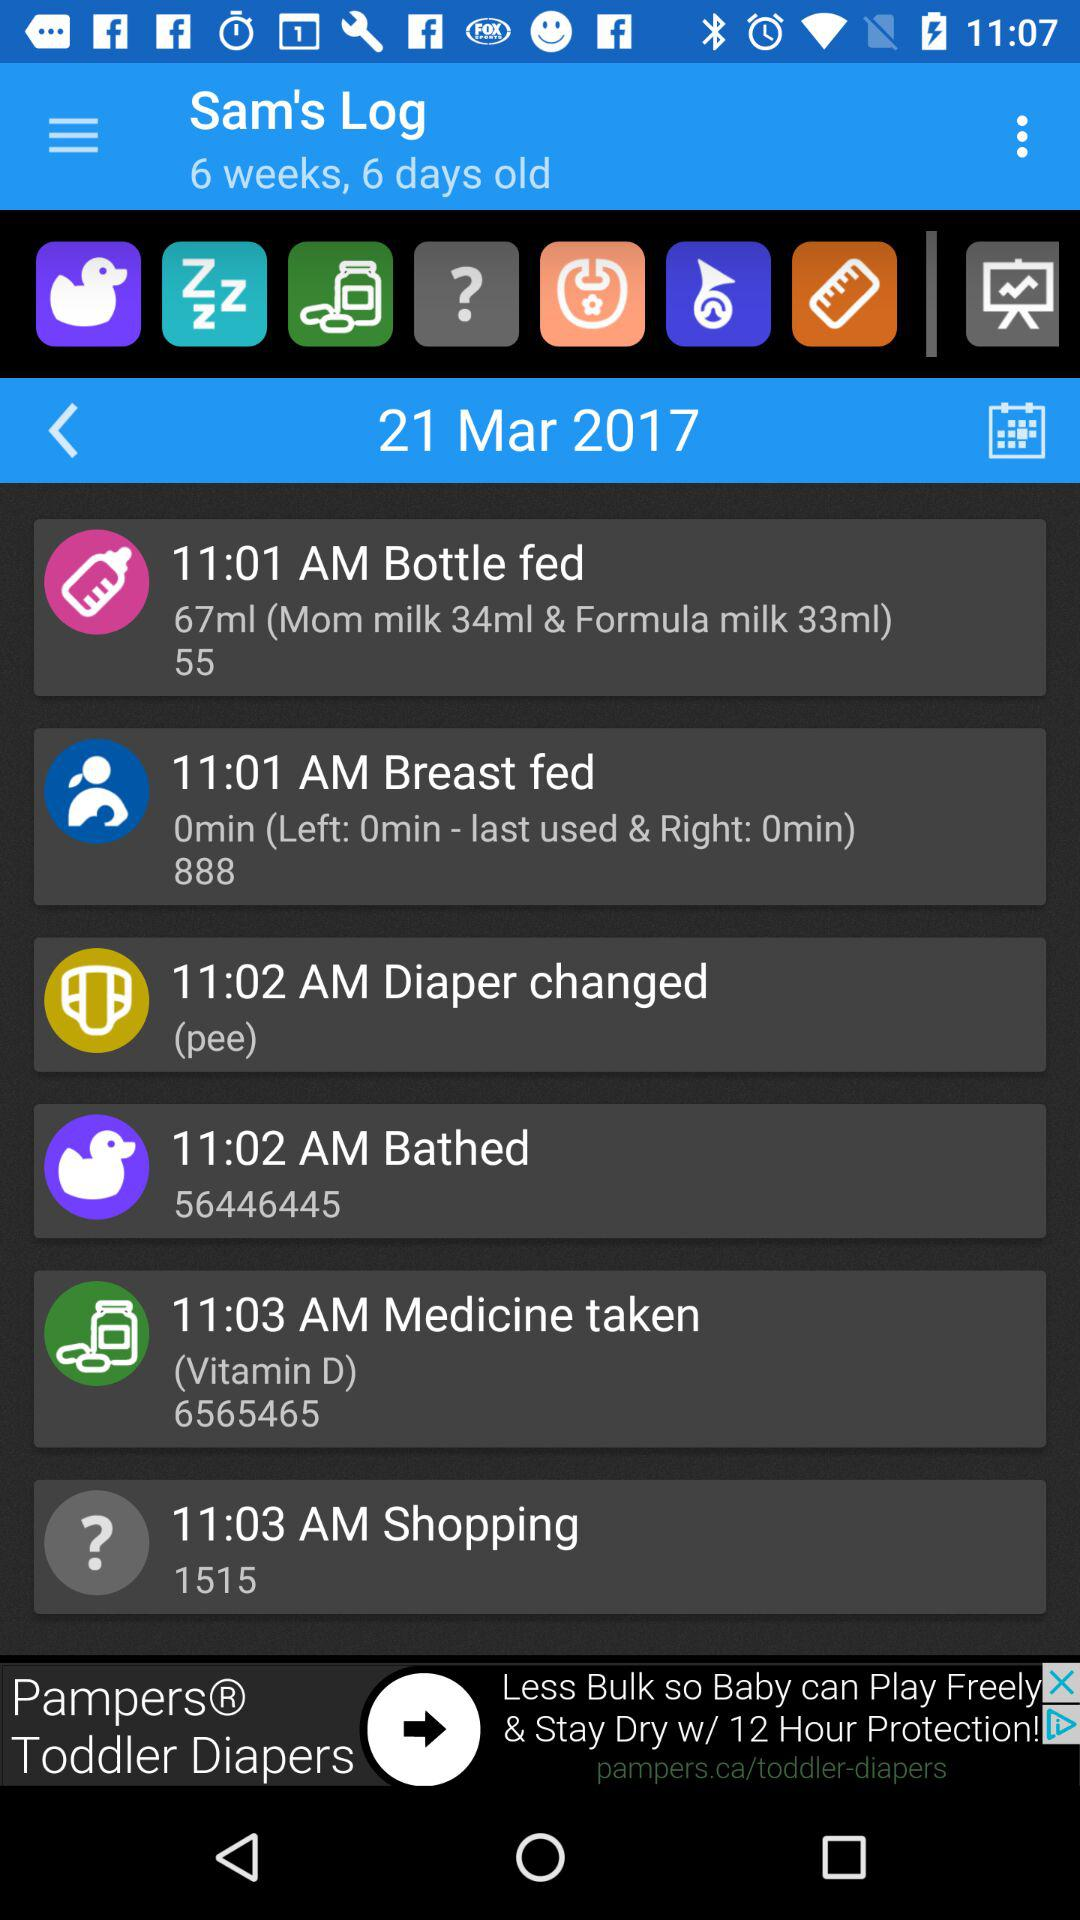What is the time for shopping? The time for shopping is 11:03 AM. 